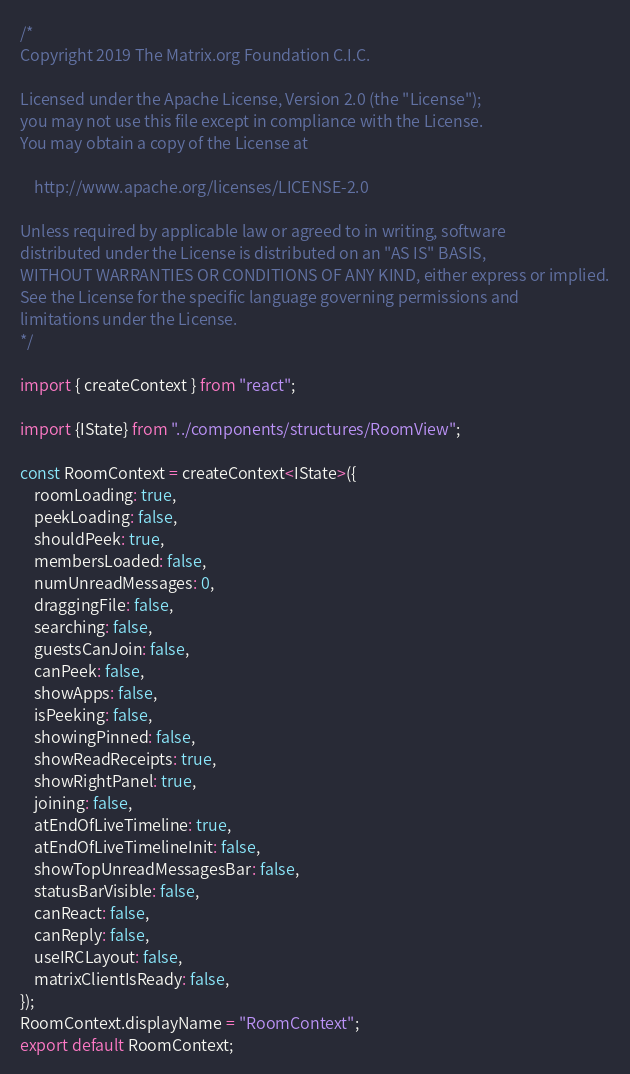Convert code to text. <code><loc_0><loc_0><loc_500><loc_500><_TypeScript_>/*
Copyright 2019 The Matrix.org Foundation C.I.C.

Licensed under the Apache License, Version 2.0 (the "License");
you may not use this file except in compliance with the License.
You may obtain a copy of the License at

    http://www.apache.org/licenses/LICENSE-2.0

Unless required by applicable law or agreed to in writing, software
distributed under the License is distributed on an "AS IS" BASIS,
WITHOUT WARRANTIES OR CONDITIONS OF ANY KIND, either express or implied.
See the License for the specific language governing permissions and
limitations under the License.
*/

import { createContext } from "react";

import {IState} from "../components/structures/RoomView";

const RoomContext = createContext<IState>({
    roomLoading: true,
    peekLoading: false,
    shouldPeek: true,
    membersLoaded: false,
    numUnreadMessages: 0,
    draggingFile: false,
    searching: false,
    guestsCanJoin: false,
    canPeek: false,
    showApps: false,
    isPeeking: false,
    showingPinned: false,
    showReadReceipts: true,
    showRightPanel: true,
    joining: false,
    atEndOfLiveTimeline: true,
    atEndOfLiveTimelineInit: false,
    showTopUnreadMessagesBar: false,
    statusBarVisible: false,
    canReact: false,
    canReply: false,
    useIRCLayout: false,
    matrixClientIsReady: false,
});
RoomContext.displayName = "RoomContext";
export default RoomContext;
</code> 